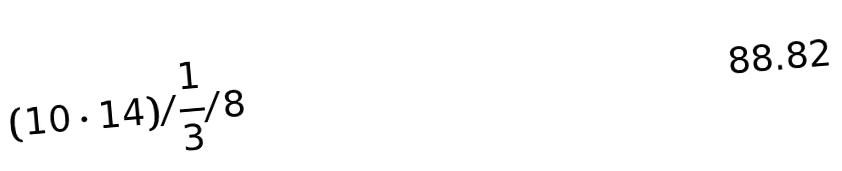Convert formula to latex. <formula><loc_0><loc_0><loc_500><loc_500>( 1 0 \cdot 1 4 ) / \frac { 1 } { 3 } / 8</formula> 